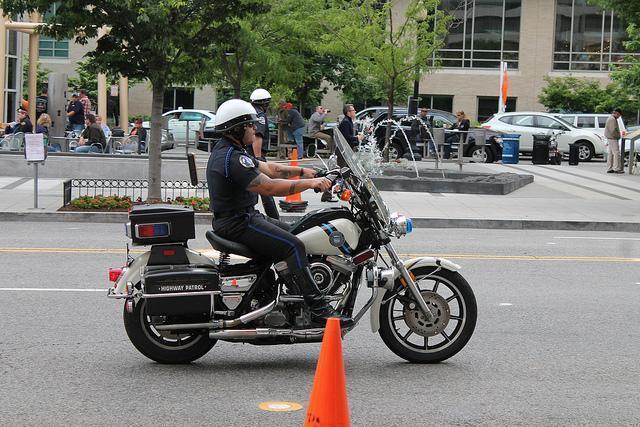Where is the officer riding here?
Pick the right solution, then justify: 'Answer: answer
Rationale: rationale.'
Options: Parade route, brazil, fire, perp. capture. Answer: parade route.
Rationale: The officer is on a route. 